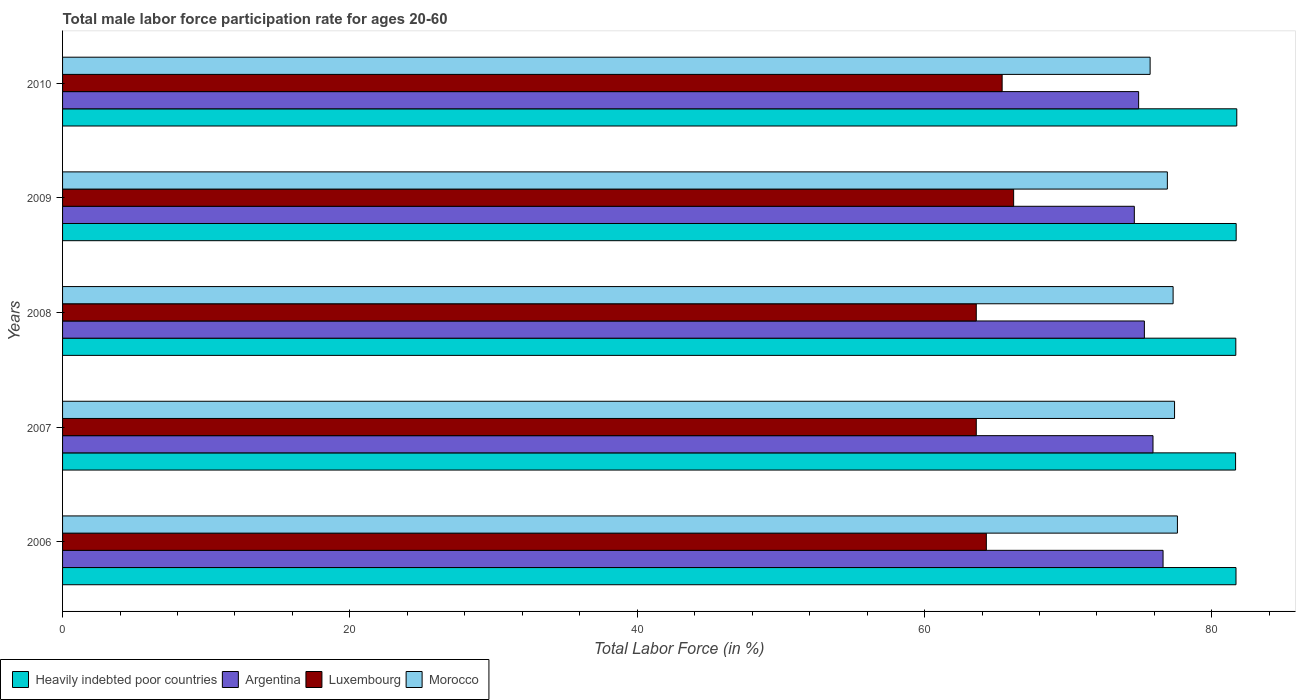How many different coloured bars are there?
Make the answer very short. 4. Are the number of bars on each tick of the Y-axis equal?
Your answer should be very brief. Yes. How many bars are there on the 3rd tick from the top?
Your answer should be compact. 4. How many bars are there on the 4th tick from the bottom?
Offer a terse response. 4. What is the label of the 2nd group of bars from the top?
Your response must be concise. 2009. What is the male labor force participation rate in Luxembourg in 2008?
Make the answer very short. 63.6. Across all years, what is the maximum male labor force participation rate in Argentina?
Give a very brief answer. 76.6. Across all years, what is the minimum male labor force participation rate in Morocco?
Offer a very short reply. 75.7. In which year was the male labor force participation rate in Heavily indebted poor countries maximum?
Keep it short and to the point. 2010. What is the total male labor force participation rate in Argentina in the graph?
Offer a very short reply. 377.3. What is the difference between the male labor force participation rate in Luxembourg in 2006 and that in 2007?
Offer a terse response. 0.7. What is the difference between the male labor force participation rate in Heavily indebted poor countries in 2006 and the male labor force participation rate in Luxembourg in 2009?
Your response must be concise. 15.48. What is the average male labor force participation rate in Luxembourg per year?
Offer a terse response. 64.62. In the year 2007, what is the difference between the male labor force participation rate in Argentina and male labor force participation rate in Morocco?
Make the answer very short. -1.5. What is the ratio of the male labor force participation rate in Argentina in 2006 to that in 2009?
Make the answer very short. 1.03. What is the difference between the highest and the second highest male labor force participation rate in Argentina?
Give a very brief answer. 0.7. What is the difference between the highest and the lowest male labor force participation rate in Luxembourg?
Ensure brevity in your answer.  2.6. In how many years, is the male labor force participation rate in Heavily indebted poor countries greater than the average male labor force participation rate in Heavily indebted poor countries taken over all years?
Keep it short and to the point. 2. Is it the case that in every year, the sum of the male labor force participation rate in Morocco and male labor force participation rate in Argentina is greater than the sum of male labor force participation rate in Luxembourg and male labor force participation rate in Heavily indebted poor countries?
Your response must be concise. No. What does the 3rd bar from the top in 2007 represents?
Your answer should be compact. Argentina. How many bars are there?
Provide a short and direct response. 20. Does the graph contain any zero values?
Provide a short and direct response. No. Where does the legend appear in the graph?
Keep it short and to the point. Bottom left. How are the legend labels stacked?
Give a very brief answer. Horizontal. What is the title of the graph?
Make the answer very short. Total male labor force participation rate for ages 20-60. Does "Jordan" appear as one of the legend labels in the graph?
Provide a succinct answer. No. What is the label or title of the X-axis?
Provide a short and direct response. Total Labor Force (in %). What is the Total Labor Force (in %) of Heavily indebted poor countries in 2006?
Offer a terse response. 81.68. What is the Total Labor Force (in %) of Argentina in 2006?
Give a very brief answer. 76.6. What is the Total Labor Force (in %) in Luxembourg in 2006?
Your response must be concise. 64.3. What is the Total Labor Force (in %) of Morocco in 2006?
Give a very brief answer. 77.6. What is the Total Labor Force (in %) in Heavily indebted poor countries in 2007?
Keep it short and to the point. 81.65. What is the Total Labor Force (in %) of Argentina in 2007?
Make the answer very short. 75.9. What is the Total Labor Force (in %) of Luxembourg in 2007?
Your response must be concise. 63.6. What is the Total Labor Force (in %) of Morocco in 2007?
Provide a short and direct response. 77.4. What is the Total Labor Force (in %) of Heavily indebted poor countries in 2008?
Provide a succinct answer. 81.66. What is the Total Labor Force (in %) of Argentina in 2008?
Provide a short and direct response. 75.3. What is the Total Labor Force (in %) of Luxembourg in 2008?
Provide a succinct answer. 63.6. What is the Total Labor Force (in %) in Morocco in 2008?
Make the answer very short. 77.3. What is the Total Labor Force (in %) in Heavily indebted poor countries in 2009?
Offer a very short reply. 81.69. What is the Total Labor Force (in %) in Argentina in 2009?
Provide a succinct answer. 74.6. What is the Total Labor Force (in %) in Luxembourg in 2009?
Offer a terse response. 66.2. What is the Total Labor Force (in %) of Morocco in 2009?
Provide a succinct answer. 76.9. What is the Total Labor Force (in %) of Heavily indebted poor countries in 2010?
Make the answer very short. 81.73. What is the Total Labor Force (in %) of Argentina in 2010?
Offer a very short reply. 74.9. What is the Total Labor Force (in %) of Luxembourg in 2010?
Ensure brevity in your answer.  65.4. What is the Total Labor Force (in %) in Morocco in 2010?
Offer a terse response. 75.7. Across all years, what is the maximum Total Labor Force (in %) in Heavily indebted poor countries?
Provide a succinct answer. 81.73. Across all years, what is the maximum Total Labor Force (in %) in Argentina?
Your answer should be compact. 76.6. Across all years, what is the maximum Total Labor Force (in %) of Luxembourg?
Offer a terse response. 66.2. Across all years, what is the maximum Total Labor Force (in %) in Morocco?
Your answer should be very brief. 77.6. Across all years, what is the minimum Total Labor Force (in %) in Heavily indebted poor countries?
Ensure brevity in your answer.  81.65. Across all years, what is the minimum Total Labor Force (in %) in Argentina?
Provide a succinct answer. 74.6. Across all years, what is the minimum Total Labor Force (in %) of Luxembourg?
Your response must be concise. 63.6. Across all years, what is the minimum Total Labor Force (in %) of Morocco?
Give a very brief answer. 75.7. What is the total Total Labor Force (in %) in Heavily indebted poor countries in the graph?
Keep it short and to the point. 408.41. What is the total Total Labor Force (in %) of Argentina in the graph?
Make the answer very short. 377.3. What is the total Total Labor Force (in %) in Luxembourg in the graph?
Your response must be concise. 323.1. What is the total Total Labor Force (in %) in Morocco in the graph?
Offer a terse response. 384.9. What is the difference between the Total Labor Force (in %) in Heavily indebted poor countries in 2006 and that in 2007?
Provide a succinct answer. 0.03. What is the difference between the Total Labor Force (in %) in Morocco in 2006 and that in 2007?
Provide a succinct answer. 0.2. What is the difference between the Total Labor Force (in %) of Heavily indebted poor countries in 2006 and that in 2008?
Give a very brief answer. 0.01. What is the difference between the Total Labor Force (in %) in Argentina in 2006 and that in 2008?
Provide a short and direct response. 1.3. What is the difference between the Total Labor Force (in %) of Morocco in 2006 and that in 2008?
Your response must be concise. 0.3. What is the difference between the Total Labor Force (in %) in Heavily indebted poor countries in 2006 and that in 2009?
Your answer should be very brief. -0.01. What is the difference between the Total Labor Force (in %) of Argentina in 2006 and that in 2009?
Provide a short and direct response. 2. What is the difference between the Total Labor Force (in %) of Luxembourg in 2006 and that in 2009?
Offer a terse response. -1.9. What is the difference between the Total Labor Force (in %) of Morocco in 2006 and that in 2009?
Give a very brief answer. 0.7. What is the difference between the Total Labor Force (in %) in Heavily indebted poor countries in 2006 and that in 2010?
Provide a short and direct response. -0.05. What is the difference between the Total Labor Force (in %) in Morocco in 2006 and that in 2010?
Ensure brevity in your answer.  1.9. What is the difference between the Total Labor Force (in %) of Heavily indebted poor countries in 2007 and that in 2008?
Offer a terse response. -0.02. What is the difference between the Total Labor Force (in %) in Argentina in 2007 and that in 2008?
Offer a terse response. 0.6. What is the difference between the Total Labor Force (in %) of Heavily indebted poor countries in 2007 and that in 2009?
Your answer should be very brief. -0.04. What is the difference between the Total Labor Force (in %) in Luxembourg in 2007 and that in 2009?
Offer a very short reply. -2.6. What is the difference between the Total Labor Force (in %) of Morocco in 2007 and that in 2009?
Make the answer very short. 0.5. What is the difference between the Total Labor Force (in %) in Heavily indebted poor countries in 2007 and that in 2010?
Ensure brevity in your answer.  -0.08. What is the difference between the Total Labor Force (in %) in Argentina in 2007 and that in 2010?
Keep it short and to the point. 1. What is the difference between the Total Labor Force (in %) in Heavily indebted poor countries in 2008 and that in 2009?
Offer a terse response. -0.03. What is the difference between the Total Labor Force (in %) of Luxembourg in 2008 and that in 2009?
Keep it short and to the point. -2.6. What is the difference between the Total Labor Force (in %) of Morocco in 2008 and that in 2009?
Ensure brevity in your answer.  0.4. What is the difference between the Total Labor Force (in %) in Heavily indebted poor countries in 2008 and that in 2010?
Offer a very short reply. -0.07. What is the difference between the Total Labor Force (in %) in Argentina in 2008 and that in 2010?
Provide a short and direct response. 0.4. What is the difference between the Total Labor Force (in %) of Luxembourg in 2008 and that in 2010?
Ensure brevity in your answer.  -1.8. What is the difference between the Total Labor Force (in %) of Heavily indebted poor countries in 2009 and that in 2010?
Offer a very short reply. -0.04. What is the difference between the Total Labor Force (in %) in Argentina in 2009 and that in 2010?
Ensure brevity in your answer.  -0.3. What is the difference between the Total Labor Force (in %) of Heavily indebted poor countries in 2006 and the Total Labor Force (in %) of Argentina in 2007?
Offer a terse response. 5.78. What is the difference between the Total Labor Force (in %) of Heavily indebted poor countries in 2006 and the Total Labor Force (in %) of Luxembourg in 2007?
Ensure brevity in your answer.  18.08. What is the difference between the Total Labor Force (in %) in Heavily indebted poor countries in 2006 and the Total Labor Force (in %) in Morocco in 2007?
Provide a short and direct response. 4.28. What is the difference between the Total Labor Force (in %) in Argentina in 2006 and the Total Labor Force (in %) in Luxembourg in 2007?
Offer a very short reply. 13. What is the difference between the Total Labor Force (in %) of Luxembourg in 2006 and the Total Labor Force (in %) of Morocco in 2007?
Offer a terse response. -13.1. What is the difference between the Total Labor Force (in %) of Heavily indebted poor countries in 2006 and the Total Labor Force (in %) of Argentina in 2008?
Your response must be concise. 6.38. What is the difference between the Total Labor Force (in %) in Heavily indebted poor countries in 2006 and the Total Labor Force (in %) in Luxembourg in 2008?
Make the answer very short. 18.08. What is the difference between the Total Labor Force (in %) of Heavily indebted poor countries in 2006 and the Total Labor Force (in %) of Morocco in 2008?
Offer a terse response. 4.38. What is the difference between the Total Labor Force (in %) in Argentina in 2006 and the Total Labor Force (in %) in Morocco in 2008?
Your response must be concise. -0.7. What is the difference between the Total Labor Force (in %) of Heavily indebted poor countries in 2006 and the Total Labor Force (in %) of Argentina in 2009?
Offer a very short reply. 7.08. What is the difference between the Total Labor Force (in %) of Heavily indebted poor countries in 2006 and the Total Labor Force (in %) of Luxembourg in 2009?
Your answer should be compact. 15.48. What is the difference between the Total Labor Force (in %) in Heavily indebted poor countries in 2006 and the Total Labor Force (in %) in Morocco in 2009?
Provide a short and direct response. 4.78. What is the difference between the Total Labor Force (in %) in Argentina in 2006 and the Total Labor Force (in %) in Luxembourg in 2009?
Keep it short and to the point. 10.4. What is the difference between the Total Labor Force (in %) of Heavily indebted poor countries in 2006 and the Total Labor Force (in %) of Argentina in 2010?
Make the answer very short. 6.78. What is the difference between the Total Labor Force (in %) in Heavily indebted poor countries in 2006 and the Total Labor Force (in %) in Luxembourg in 2010?
Make the answer very short. 16.28. What is the difference between the Total Labor Force (in %) of Heavily indebted poor countries in 2006 and the Total Labor Force (in %) of Morocco in 2010?
Provide a succinct answer. 5.98. What is the difference between the Total Labor Force (in %) of Argentina in 2006 and the Total Labor Force (in %) of Morocco in 2010?
Provide a succinct answer. 0.9. What is the difference between the Total Labor Force (in %) in Luxembourg in 2006 and the Total Labor Force (in %) in Morocco in 2010?
Your response must be concise. -11.4. What is the difference between the Total Labor Force (in %) in Heavily indebted poor countries in 2007 and the Total Labor Force (in %) in Argentina in 2008?
Your answer should be compact. 6.35. What is the difference between the Total Labor Force (in %) of Heavily indebted poor countries in 2007 and the Total Labor Force (in %) of Luxembourg in 2008?
Your answer should be compact. 18.05. What is the difference between the Total Labor Force (in %) in Heavily indebted poor countries in 2007 and the Total Labor Force (in %) in Morocco in 2008?
Provide a short and direct response. 4.35. What is the difference between the Total Labor Force (in %) in Argentina in 2007 and the Total Labor Force (in %) in Morocco in 2008?
Offer a very short reply. -1.4. What is the difference between the Total Labor Force (in %) in Luxembourg in 2007 and the Total Labor Force (in %) in Morocco in 2008?
Your answer should be very brief. -13.7. What is the difference between the Total Labor Force (in %) in Heavily indebted poor countries in 2007 and the Total Labor Force (in %) in Argentina in 2009?
Your response must be concise. 7.05. What is the difference between the Total Labor Force (in %) of Heavily indebted poor countries in 2007 and the Total Labor Force (in %) of Luxembourg in 2009?
Your response must be concise. 15.45. What is the difference between the Total Labor Force (in %) of Heavily indebted poor countries in 2007 and the Total Labor Force (in %) of Morocco in 2009?
Provide a short and direct response. 4.75. What is the difference between the Total Labor Force (in %) of Argentina in 2007 and the Total Labor Force (in %) of Luxembourg in 2009?
Provide a short and direct response. 9.7. What is the difference between the Total Labor Force (in %) of Argentina in 2007 and the Total Labor Force (in %) of Morocco in 2009?
Give a very brief answer. -1. What is the difference between the Total Labor Force (in %) in Luxembourg in 2007 and the Total Labor Force (in %) in Morocco in 2009?
Provide a short and direct response. -13.3. What is the difference between the Total Labor Force (in %) of Heavily indebted poor countries in 2007 and the Total Labor Force (in %) of Argentina in 2010?
Your answer should be very brief. 6.75. What is the difference between the Total Labor Force (in %) in Heavily indebted poor countries in 2007 and the Total Labor Force (in %) in Luxembourg in 2010?
Give a very brief answer. 16.25. What is the difference between the Total Labor Force (in %) in Heavily indebted poor countries in 2007 and the Total Labor Force (in %) in Morocco in 2010?
Keep it short and to the point. 5.95. What is the difference between the Total Labor Force (in %) of Argentina in 2007 and the Total Labor Force (in %) of Luxembourg in 2010?
Give a very brief answer. 10.5. What is the difference between the Total Labor Force (in %) in Heavily indebted poor countries in 2008 and the Total Labor Force (in %) in Argentina in 2009?
Provide a succinct answer. 7.06. What is the difference between the Total Labor Force (in %) in Heavily indebted poor countries in 2008 and the Total Labor Force (in %) in Luxembourg in 2009?
Your response must be concise. 15.46. What is the difference between the Total Labor Force (in %) of Heavily indebted poor countries in 2008 and the Total Labor Force (in %) of Morocco in 2009?
Your response must be concise. 4.76. What is the difference between the Total Labor Force (in %) in Argentina in 2008 and the Total Labor Force (in %) in Morocco in 2009?
Give a very brief answer. -1.6. What is the difference between the Total Labor Force (in %) of Heavily indebted poor countries in 2008 and the Total Labor Force (in %) of Argentina in 2010?
Offer a terse response. 6.76. What is the difference between the Total Labor Force (in %) of Heavily indebted poor countries in 2008 and the Total Labor Force (in %) of Luxembourg in 2010?
Provide a short and direct response. 16.26. What is the difference between the Total Labor Force (in %) of Heavily indebted poor countries in 2008 and the Total Labor Force (in %) of Morocco in 2010?
Provide a succinct answer. 5.96. What is the difference between the Total Labor Force (in %) in Argentina in 2008 and the Total Labor Force (in %) in Luxembourg in 2010?
Keep it short and to the point. 9.9. What is the difference between the Total Labor Force (in %) of Argentina in 2008 and the Total Labor Force (in %) of Morocco in 2010?
Your answer should be very brief. -0.4. What is the difference between the Total Labor Force (in %) of Heavily indebted poor countries in 2009 and the Total Labor Force (in %) of Argentina in 2010?
Ensure brevity in your answer.  6.79. What is the difference between the Total Labor Force (in %) of Heavily indebted poor countries in 2009 and the Total Labor Force (in %) of Luxembourg in 2010?
Provide a succinct answer. 16.29. What is the difference between the Total Labor Force (in %) of Heavily indebted poor countries in 2009 and the Total Labor Force (in %) of Morocco in 2010?
Give a very brief answer. 5.99. What is the average Total Labor Force (in %) in Heavily indebted poor countries per year?
Your answer should be very brief. 81.68. What is the average Total Labor Force (in %) of Argentina per year?
Keep it short and to the point. 75.46. What is the average Total Labor Force (in %) in Luxembourg per year?
Ensure brevity in your answer.  64.62. What is the average Total Labor Force (in %) of Morocco per year?
Provide a succinct answer. 76.98. In the year 2006, what is the difference between the Total Labor Force (in %) in Heavily indebted poor countries and Total Labor Force (in %) in Argentina?
Keep it short and to the point. 5.08. In the year 2006, what is the difference between the Total Labor Force (in %) of Heavily indebted poor countries and Total Labor Force (in %) of Luxembourg?
Give a very brief answer. 17.38. In the year 2006, what is the difference between the Total Labor Force (in %) in Heavily indebted poor countries and Total Labor Force (in %) in Morocco?
Offer a terse response. 4.08. In the year 2006, what is the difference between the Total Labor Force (in %) in Argentina and Total Labor Force (in %) in Morocco?
Keep it short and to the point. -1. In the year 2007, what is the difference between the Total Labor Force (in %) of Heavily indebted poor countries and Total Labor Force (in %) of Argentina?
Ensure brevity in your answer.  5.75. In the year 2007, what is the difference between the Total Labor Force (in %) in Heavily indebted poor countries and Total Labor Force (in %) in Luxembourg?
Make the answer very short. 18.05. In the year 2007, what is the difference between the Total Labor Force (in %) of Heavily indebted poor countries and Total Labor Force (in %) of Morocco?
Your answer should be very brief. 4.25. In the year 2007, what is the difference between the Total Labor Force (in %) of Argentina and Total Labor Force (in %) of Morocco?
Make the answer very short. -1.5. In the year 2007, what is the difference between the Total Labor Force (in %) of Luxembourg and Total Labor Force (in %) of Morocco?
Provide a short and direct response. -13.8. In the year 2008, what is the difference between the Total Labor Force (in %) of Heavily indebted poor countries and Total Labor Force (in %) of Argentina?
Provide a short and direct response. 6.36. In the year 2008, what is the difference between the Total Labor Force (in %) in Heavily indebted poor countries and Total Labor Force (in %) in Luxembourg?
Ensure brevity in your answer.  18.06. In the year 2008, what is the difference between the Total Labor Force (in %) of Heavily indebted poor countries and Total Labor Force (in %) of Morocco?
Provide a short and direct response. 4.36. In the year 2008, what is the difference between the Total Labor Force (in %) of Argentina and Total Labor Force (in %) of Luxembourg?
Offer a terse response. 11.7. In the year 2008, what is the difference between the Total Labor Force (in %) of Luxembourg and Total Labor Force (in %) of Morocco?
Make the answer very short. -13.7. In the year 2009, what is the difference between the Total Labor Force (in %) in Heavily indebted poor countries and Total Labor Force (in %) in Argentina?
Give a very brief answer. 7.09. In the year 2009, what is the difference between the Total Labor Force (in %) of Heavily indebted poor countries and Total Labor Force (in %) of Luxembourg?
Offer a terse response. 15.49. In the year 2009, what is the difference between the Total Labor Force (in %) in Heavily indebted poor countries and Total Labor Force (in %) in Morocco?
Offer a very short reply. 4.79. In the year 2009, what is the difference between the Total Labor Force (in %) in Luxembourg and Total Labor Force (in %) in Morocco?
Ensure brevity in your answer.  -10.7. In the year 2010, what is the difference between the Total Labor Force (in %) of Heavily indebted poor countries and Total Labor Force (in %) of Argentina?
Give a very brief answer. 6.83. In the year 2010, what is the difference between the Total Labor Force (in %) of Heavily indebted poor countries and Total Labor Force (in %) of Luxembourg?
Ensure brevity in your answer.  16.33. In the year 2010, what is the difference between the Total Labor Force (in %) of Heavily indebted poor countries and Total Labor Force (in %) of Morocco?
Your response must be concise. 6.03. What is the ratio of the Total Labor Force (in %) in Argentina in 2006 to that in 2007?
Make the answer very short. 1.01. What is the ratio of the Total Labor Force (in %) in Morocco in 2006 to that in 2007?
Keep it short and to the point. 1. What is the ratio of the Total Labor Force (in %) of Heavily indebted poor countries in 2006 to that in 2008?
Your answer should be compact. 1. What is the ratio of the Total Labor Force (in %) in Argentina in 2006 to that in 2008?
Your answer should be very brief. 1.02. What is the ratio of the Total Labor Force (in %) in Morocco in 2006 to that in 2008?
Provide a succinct answer. 1. What is the ratio of the Total Labor Force (in %) in Argentina in 2006 to that in 2009?
Give a very brief answer. 1.03. What is the ratio of the Total Labor Force (in %) in Luxembourg in 2006 to that in 2009?
Your answer should be compact. 0.97. What is the ratio of the Total Labor Force (in %) in Morocco in 2006 to that in 2009?
Keep it short and to the point. 1.01. What is the ratio of the Total Labor Force (in %) in Argentina in 2006 to that in 2010?
Your answer should be compact. 1.02. What is the ratio of the Total Labor Force (in %) in Luxembourg in 2006 to that in 2010?
Keep it short and to the point. 0.98. What is the ratio of the Total Labor Force (in %) of Morocco in 2006 to that in 2010?
Provide a short and direct response. 1.03. What is the ratio of the Total Labor Force (in %) in Argentina in 2007 to that in 2008?
Your answer should be very brief. 1.01. What is the ratio of the Total Labor Force (in %) of Luxembourg in 2007 to that in 2008?
Your answer should be compact. 1. What is the ratio of the Total Labor Force (in %) of Heavily indebted poor countries in 2007 to that in 2009?
Provide a succinct answer. 1. What is the ratio of the Total Labor Force (in %) of Argentina in 2007 to that in 2009?
Offer a terse response. 1.02. What is the ratio of the Total Labor Force (in %) of Luxembourg in 2007 to that in 2009?
Give a very brief answer. 0.96. What is the ratio of the Total Labor Force (in %) of Morocco in 2007 to that in 2009?
Your response must be concise. 1.01. What is the ratio of the Total Labor Force (in %) in Heavily indebted poor countries in 2007 to that in 2010?
Offer a very short reply. 1. What is the ratio of the Total Labor Force (in %) in Argentina in 2007 to that in 2010?
Keep it short and to the point. 1.01. What is the ratio of the Total Labor Force (in %) in Luxembourg in 2007 to that in 2010?
Your answer should be very brief. 0.97. What is the ratio of the Total Labor Force (in %) of Morocco in 2007 to that in 2010?
Offer a terse response. 1.02. What is the ratio of the Total Labor Force (in %) of Argentina in 2008 to that in 2009?
Provide a succinct answer. 1.01. What is the ratio of the Total Labor Force (in %) in Luxembourg in 2008 to that in 2009?
Your answer should be compact. 0.96. What is the ratio of the Total Labor Force (in %) in Morocco in 2008 to that in 2009?
Provide a succinct answer. 1.01. What is the ratio of the Total Labor Force (in %) of Heavily indebted poor countries in 2008 to that in 2010?
Your response must be concise. 1. What is the ratio of the Total Labor Force (in %) in Luxembourg in 2008 to that in 2010?
Offer a terse response. 0.97. What is the ratio of the Total Labor Force (in %) in Morocco in 2008 to that in 2010?
Provide a short and direct response. 1.02. What is the ratio of the Total Labor Force (in %) in Luxembourg in 2009 to that in 2010?
Your response must be concise. 1.01. What is the ratio of the Total Labor Force (in %) of Morocco in 2009 to that in 2010?
Provide a short and direct response. 1.02. What is the difference between the highest and the second highest Total Labor Force (in %) of Heavily indebted poor countries?
Keep it short and to the point. 0.04. What is the difference between the highest and the second highest Total Labor Force (in %) of Argentina?
Your answer should be very brief. 0.7. What is the difference between the highest and the second highest Total Labor Force (in %) of Luxembourg?
Provide a short and direct response. 0.8. What is the difference between the highest and the second highest Total Labor Force (in %) in Morocco?
Your response must be concise. 0.2. What is the difference between the highest and the lowest Total Labor Force (in %) of Heavily indebted poor countries?
Your answer should be compact. 0.08. What is the difference between the highest and the lowest Total Labor Force (in %) of Argentina?
Give a very brief answer. 2. What is the difference between the highest and the lowest Total Labor Force (in %) in Morocco?
Ensure brevity in your answer.  1.9. 